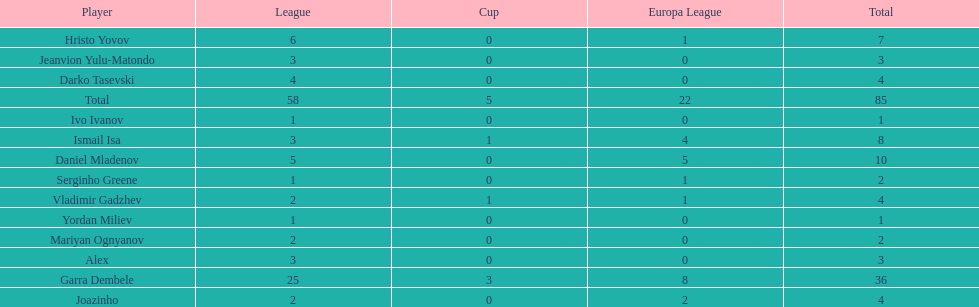How many goals did ismail isa score this season? 8. 